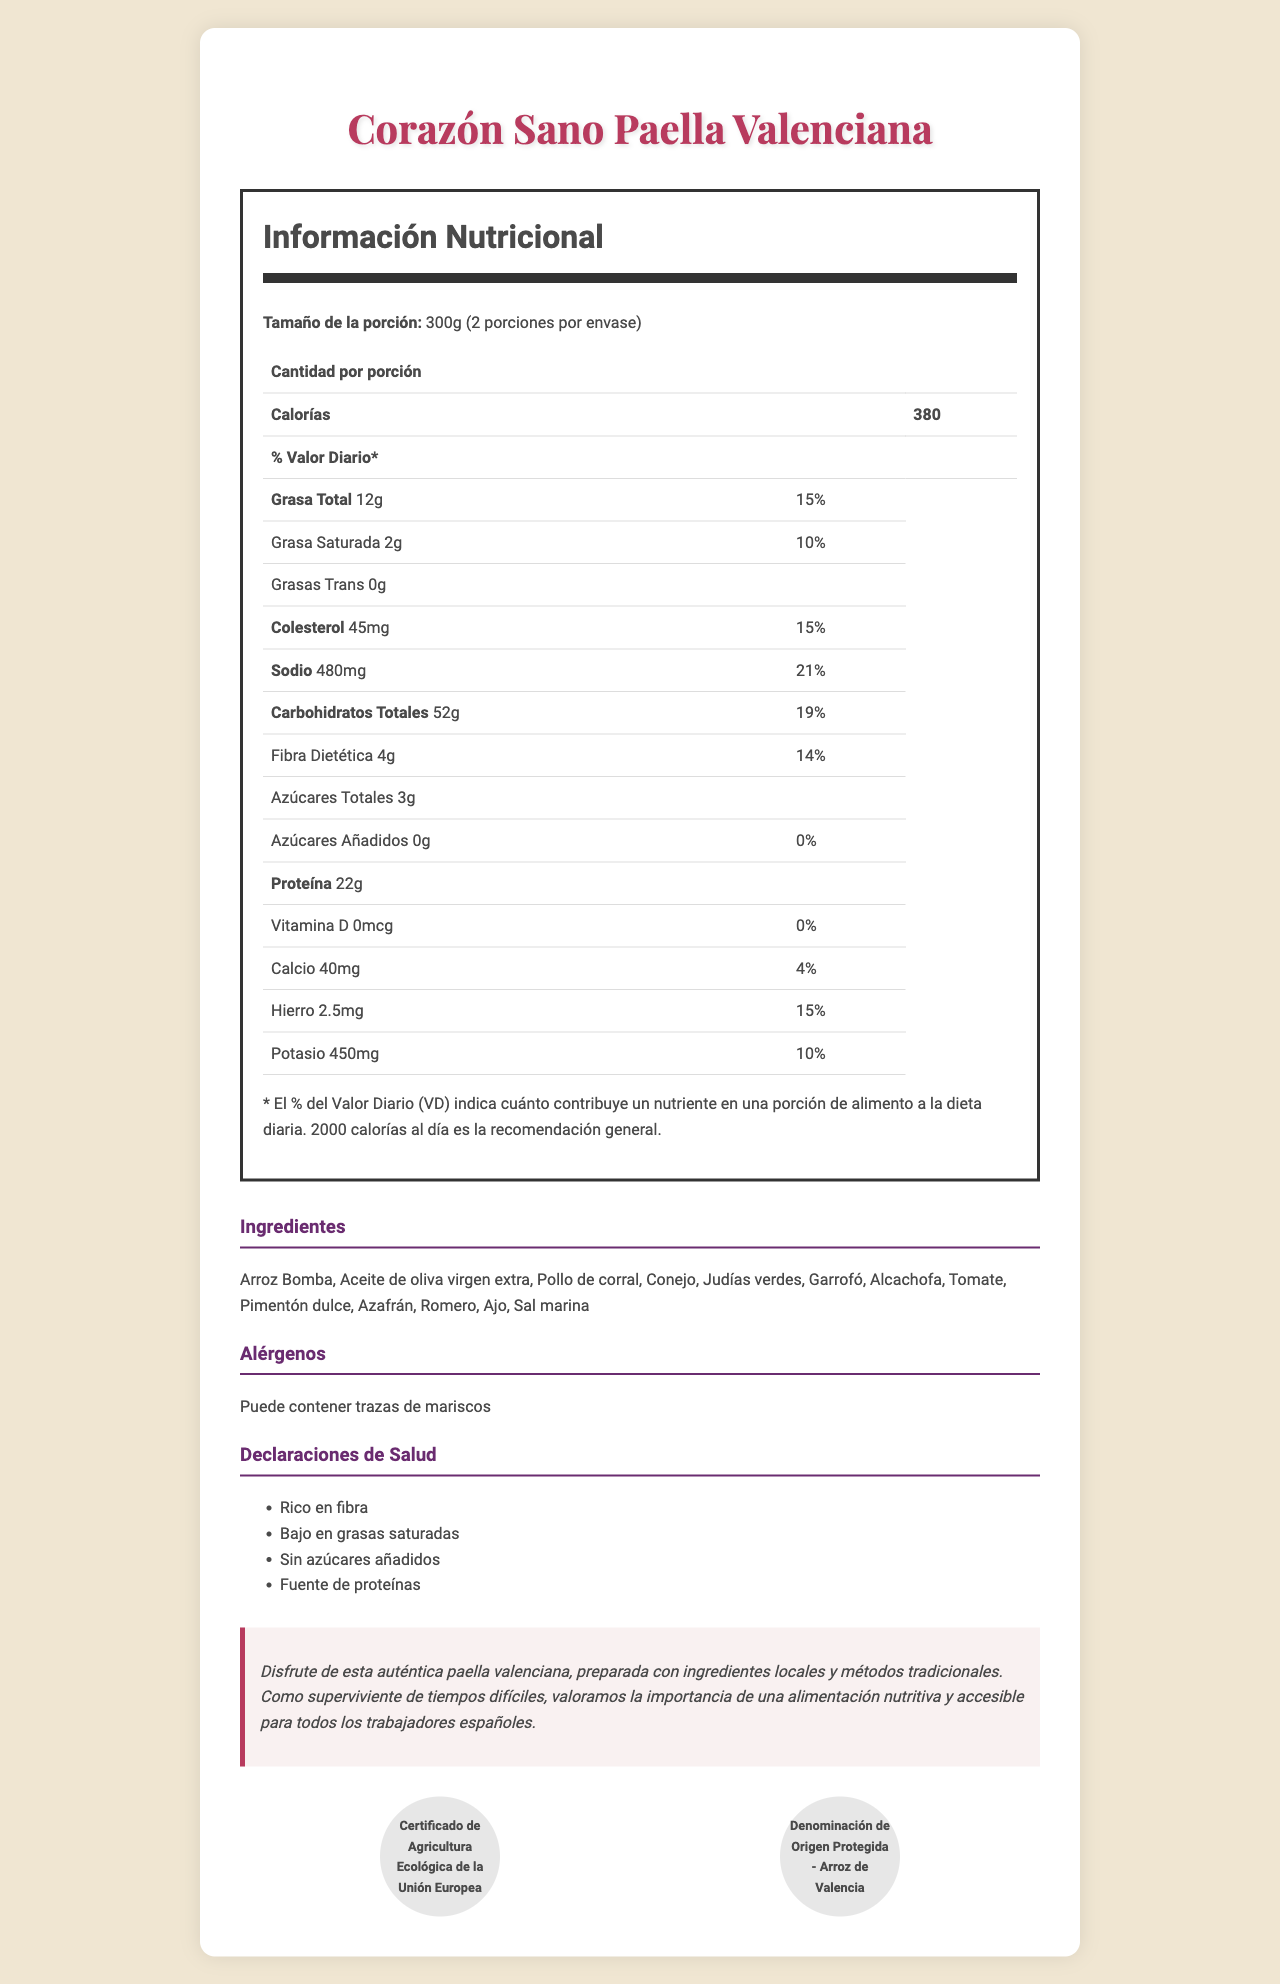what is the main product described in the document? The document prominently highlights the product name "Corazón Sano Paella Valenciana" at the top.
Answer: Corazón Sano Paella Valenciana what is the serving size of the Corazón Sano Paella Valenciana? According to the nutrition label, the serving size is specified as 300g.
Answer: 300g how many servings are there per container? The document states under the serving size section that there are 2 servings per container.
Answer: 2 what are the total calories per serving? The nutrition label states that each serving of the product has 380 calories.
Answer: 380 calories what percentage of the daily value of sodium does one serving contain? The nutrition label indicates that one serving contains 21% of the daily value for sodium.
Answer: 21% what is the amount of dietary fiber per serving? The nutrition label specifies that one serving contains 4g of dietary fiber.
Answer: 4g how much protein is there in one serving? The nutrition label highlights that one serving has 22g of protein.
Answer: 22g what are the three main sources of protein in the ingredients list? A. Garrofó, Pollo de corral, Conejo B. Judías verdes, Garrofó, Pimentón dulce C. Ajo, Sal marina, Aceite de oliva virgen extra The ingredients indicating protein sources are Garrofó, Pollo de corral (free-range chicken), and Conejo (rabbit).
Answer: A. Garrofó, Pollo de corral, Conejo which of the following is NOT included in the health claims? A. Bajo en grasas saturadas B. Sin azúcares añadidos C. Alto en grasas trans The health claims section lists "Bajo en grasas saturadas", "Sin azúcares añadidos", and a few others, but not "Alto en grasas trans".
Answer: C. Alto en grasas trans is the product suitable for a diet that avoids added sugars? (Yes/No) The document states in the health claims that the product has "Sin azúcares añadidos" (No added sugars).
Answer: Yes summarize the main purpose of this document. The document provides detailed nutrition information, ingredients list, allergens, health claims, and other relevant details about the "Corazón Sano Paella Valenciana".
Answer: The document is a comprehensive nutrition facts label for the "Corazón Sano Paella Valenciana", detailing its nutritional content, ingredients, allergens, and health benefits, along with additional preparation and storage instructions. where is the product manufactured? The manufacturer's information specifies that it is produced by "Cooperativa de Trabajadores Unidos, Valencia, España".
Answer: Valencia, España does the document mention the product containing any trans fat? The nutrition label specifically mentions that trans fat content is 0g.
Answer: No which certification is NOT listed for the product? The document lists two certifications, but without additional context, we cannot determine any other possible certifications it might have.
Answer: Not enough information what storage instructions are provided for the product? The storage instructions section advises to keep the product in a cool, dry place and to consume within 24 hours once opened.
Answer: Conservar en lugar fresco y seco. Una vez abierto, consumir en 24 horas. 